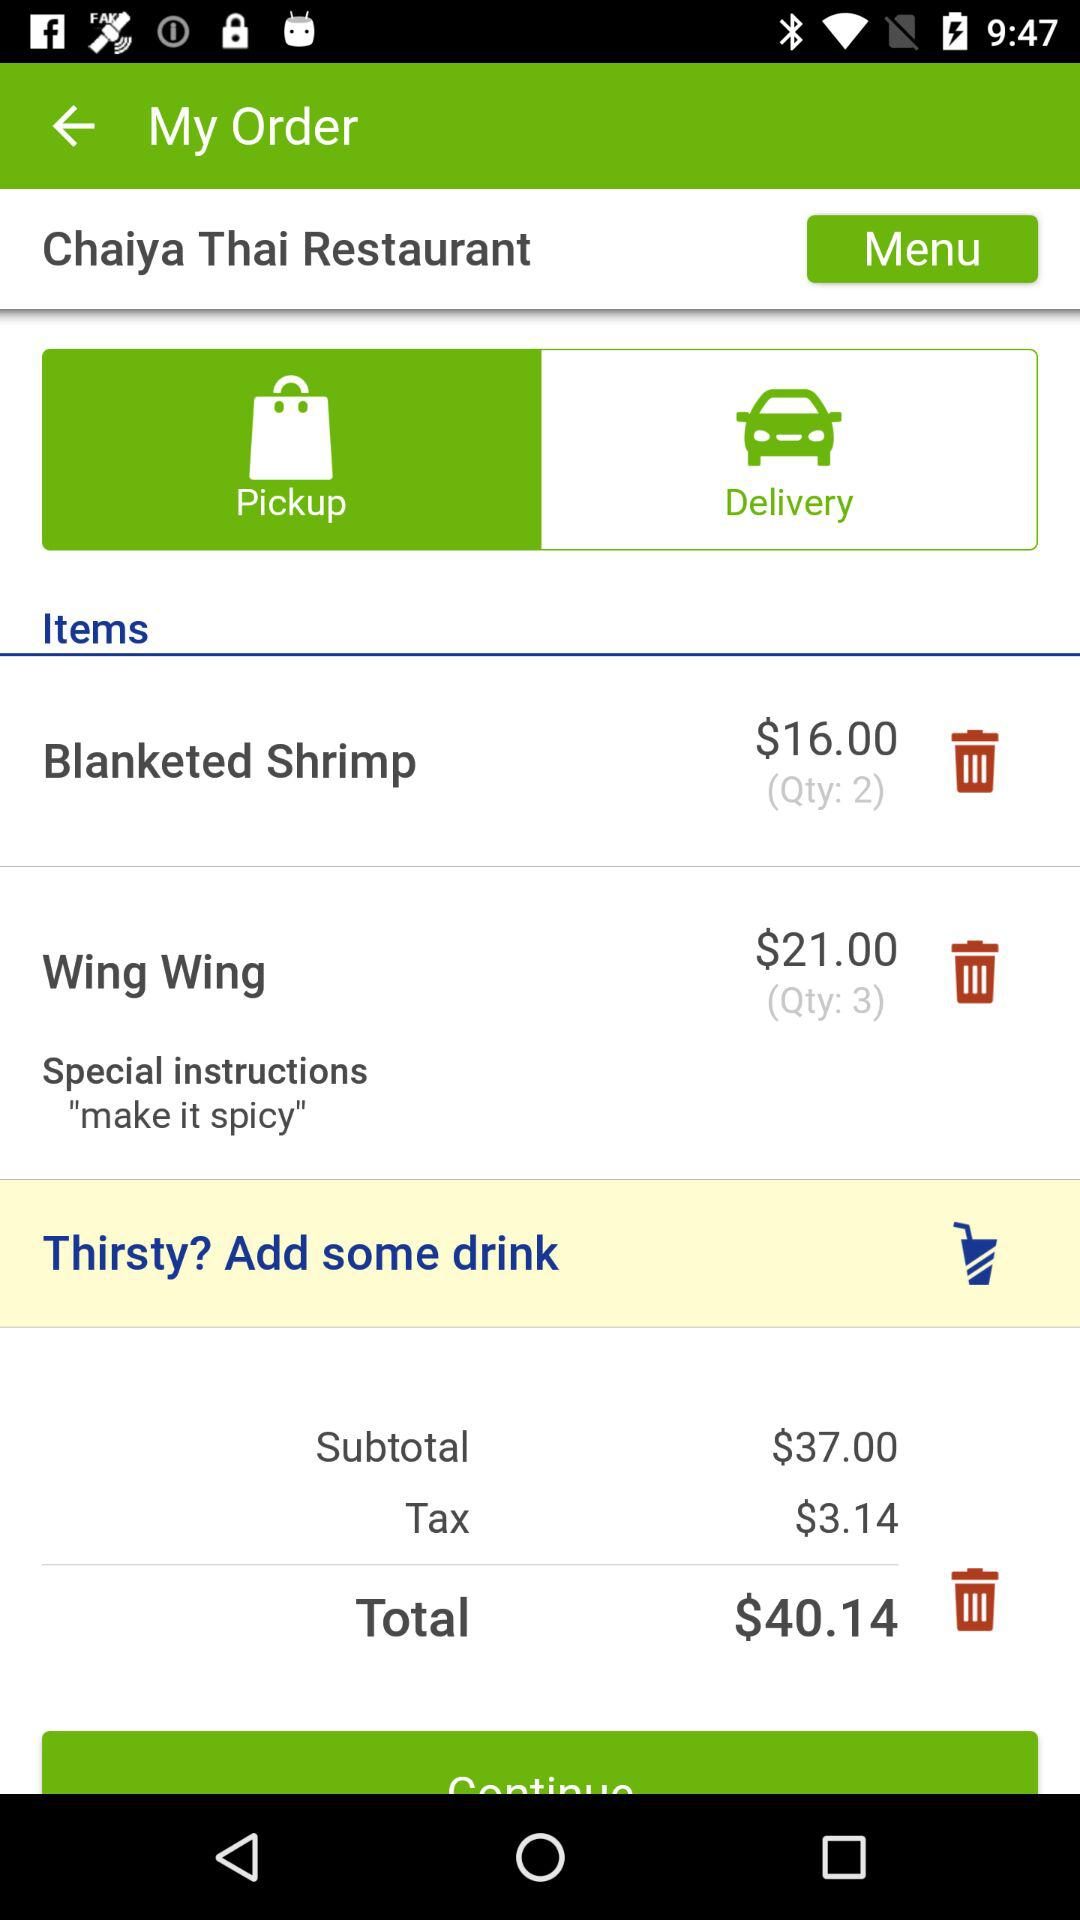What is the tax charge? The tax charge is $3.14. 